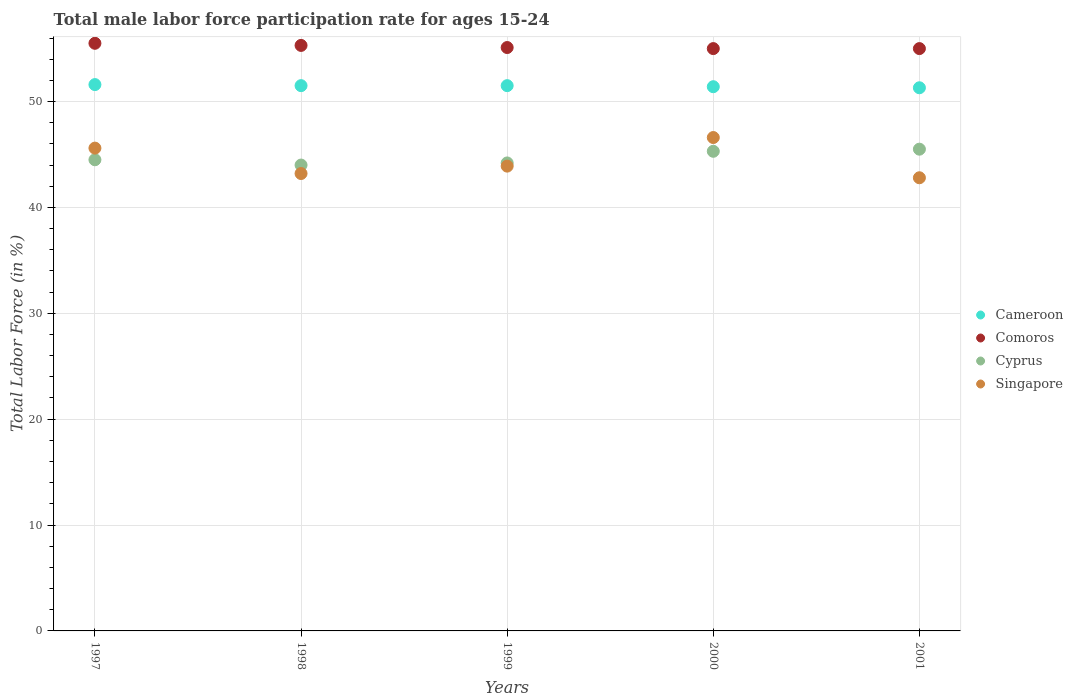How many different coloured dotlines are there?
Keep it short and to the point. 4. Is the number of dotlines equal to the number of legend labels?
Your answer should be very brief. Yes. What is the male labor force participation rate in Cameroon in 2001?
Keep it short and to the point. 51.3. Across all years, what is the maximum male labor force participation rate in Cyprus?
Provide a short and direct response. 45.5. What is the total male labor force participation rate in Cameroon in the graph?
Give a very brief answer. 257.3. What is the difference between the male labor force participation rate in Comoros in 1997 and that in 1999?
Provide a succinct answer. 0.4. What is the difference between the male labor force participation rate in Cameroon in 1997 and the male labor force participation rate in Comoros in 2001?
Your answer should be very brief. -3.4. What is the average male labor force participation rate in Singapore per year?
Your answer should be compact. 44.42. In the year 1997, what is the difference between the male labor force participation rate in Comoros and male labor force participation rate in Cyprus?
Give a very brief answer. 11. In how many years, is the male labor force participation rate in Cameroon greater than 18 %?
Give a very brief answer. 5. What is the ratio of the male labor force participation rate in Singapore in 1998 to that in 2000?
Give a very brief answer. 0.93. What is the difference between the highest and the second highest male labor force participation rate in Comoros?
Ensure brevity in your answer.  0.2. What is the difference between the highest and the lowest male labor force participation rate in Cyprus?
Provide a succinct answer. 1.5. In how many years, is the male labor force participation rate in Singapore greater than the average male labor force participation rate in Singapore taken over all years?
Keep it short and to the point. 2. Is the sum of the male labor force participation rate in Comoros in 1997 and 2000 greater than the maximum male labor force participation rate in Cyprus across all years?
Make the answer very short. Yes. Is it the case that in every year, the sum of the male labor force participation rate in Cameroon and male labor force participation rate in Comoros  is greater than the male labor force participation rate in Cyprus?
Your response must be concise. Yes. Does the male labor force participation rate in Cyprus monotonically increase over the years?
Give a very brief answer. No. Is the male labor force participation rate in Cyprus strictly less than the male labor force participation rate in Singapore over the years?
Ensure brevity in your answer.  No. How many years are there in the graph?
Your response must be concise. 5. Does the graph contain any zero values?
Your answer should be compact. No. Does the graph contain grids?
Your answer should be very brief. Yes. How many legend labels are there?
Your response must be concise. 4. How are the legend labels stacked?
Give a very brief answer. Vertical. What is the title of the graph?
Make the answer very short. Total male labor force participation rate for ages 15-24. Does "Costa Rica" appear as one of the legend labels in the graph?
Ensure brevity in your answer.  No. What is the label or title of the X-axis?
Your answer should be very brief. Years. What is the Total Labor Force (in %) in Cameroon in 1997?
Your answer should be compact. 51.6. What is the Total Labor Force (in %) in Comoros in 1997?
Ensure brevity in your answer.  55.5. What is the Total Labor Force (in %) of Cyprus in 1997?
Your answer should be compact. 44.5. What is the Total Labor Force (in %) in Singapore in 1997?
Make the answer very short. 45.6. What is the Total Labor Force (in %) of Cameroon in 1998?
Offer a terse response. 51.5. What is the Total Labor Force (in %) in Comoros in 1998?
Your answer should be very brief. 55.3. What is the Total Labor Force (in %) in Cyprus in 1998?
Your answer should be compact. 44. What is the Total Labor Force (in %) of Singapore in 1998?
Your answer should be very brief. 43.2. What is the Total Labor Force (in %) in Cameroon in 1999?
Make the answer very short. 51.5. What is the Total Labor Force (in %) of Comoros in 1999?
Provide a short and direct response. 55.1. What is the Total Labor Force (in %) in Cyprus in 1999?
Keep it short and to the point. 44.2. What is the Total Labor Force (in %) in Singapore in 1999?
Offer a terse response. 43.9. What is the Total Labor Force (in %) in Cameroon in 2000?
Make the answer very short. 51.4. What is the Total Labor Force (in %) in Comoros in 2000?
Offer a very short reply. 55. What is the Total Labor Force (in %) in Cyprus in 2000?
Offer a terse response. 45.3. What is the Total Labor Force (in %) of Singapore in 2000?
Provide a short and direct response. 46.6. What is the Total Labor Force (in %) of Cameroon in 2001?
Provide a short and direct response. 51.3. What is the Total Labor Force (in %) of Cyprus in 2001?
Your response must be concise. 45.5. What is the Total Labor Force (in %) in Singapore in 2001?
Offer a terse response. 42.8. Across all years, what is the maximum Total Labor Force (in %) in Cameroon?
Your answer should be very brief. 51.6. Across all years, what is the maximum Total Labor Force (in %) in Comoros?
Make the answer very short. 55.5. Across all years, what is the maximum Total Labor Force (in %) in Cyprus?
Your answer should be very brief. 45.5. Across all years, what is the maximum Total Labor Force (in %) in Singapore?
Your response must be concise. 46.6. Across all years, what is the minimum Total Labor Force (in %) in Cameroon?
Your answer should be very brief. 51.3. Across all years, what is the minimum Total Labor Force (in %) in Comoros?
Your answer should be very brief. 55. Across all years, what is the minimum Total Labor Force (in %) of Singapore?
Your answer should be very brief. 42.8. What is the total Total Labor Force (in %) of Cameroon in the graph?
Make the answer very short. 257.3. What is the total Total Labor Force (in %) of Comoros in the graph?
Your answer should be compact. 275.9. What is the total Total Labor Force (in %) of Cyprus in the graph?
Provide a short and direct response. 223.5. What is the total Total Labor Force (in %) of Singapore in the graph?
Your answer should be very brief. 222.1. What is the difference between the Total Labor Force (in %) of Cameroon in 1997 and that in 1998?
Your response must be concise. 0.1. What is the difference between the Total Labor Force (in %) of Comoros in 1997 and that in 1998?
Ensure brevity in your answer.  0.2. What is the difference between the Total Labor Force (in %) in Cyprus in 1997 and that in 1998?
Offer a very short reply. 0.5. What is the difference between the Total Labor Force (in %) in Singapore in 1997 and that in 1998?
Offer a very short reply. 2.4. What is the difference between the Total Labor Force (in %) in Cameroon in 1997 and that in 1999?
Offer a terse response. 0.1. What is the difference between the Total Labor Force (in %) in Cyprus in 1997 and that in 1999?
Your answer should be compact. 0.3. What is the difference between the Total Labor Force (in %) of Cameroon in 1997 and that in 2000?
Provide a short and direct response. 0.2. What is the difference between the Total Labor Force (in %) of Comoros in 1997 and that in 2000?
Keep it short and to the point. 0.5. What is the difference between the Total Labor Force (in %) of Cyprus in 1997 and that in 2000?
Your answer should be very brief. -0.8. What is the difference between the Total Labor Force (in %) in Singapore in 1997 and that in 2000?
Make the answer very short. -1. What is the difference between the Total Labor Force (in %) in Comoros in 1997 and that in 2001?
Your answer should be compact. 0.5. What is the difference between the Total Labor Force (in %) in Cyprus in 1997 and that in 2001?
Your answer should be compact. -1. What is the difference between the Total Labor Force (in %) in Singapore in 1997 and that in 2001?
Provide a succinct answer. 2.8. What is the difference between the Total Labor Force (in %) of Cameroon in 1998 and that in 1999?
Your answer should be very brief. 0. What is the difference between the Total Labor Force (in %) in Comoros in 1998 and that in 1999?
Offer a terse response. 0.2. What is the difference between the Total Labor Force (in %) of Cyprus in 1998 and that in 1999?
Offer a terse response. -0.2. What is the difference between the Total Labor Force (in %) of Cameroon in 1998 and that in 2000?
Give a very brief answer. 0.1. What is the difference between the Total Labor Force (in %) of Comoros in 1998 and that in 2000?
Make the answer very short. 0.3. What is the difference between the Total Labor Force (in %) of Cyprus in 1998 and that in 2000?
Keep it short and to the point. -1.3. What is the difference between the Total Labor Force (in %) of Singapore in 1998 and that in 2000?
Your answer should be compact. -3.4. What is the difference between the Total Labor Force (in %) in Cameroon in 1998 and that in 2001?
Offer a very short reply. 0.2. What is the difference between the Total Labor Force (in %) in Cyprus in 1998 and that in 2001?
Provide a short and direct response. -1.5. What is the difference between the Total Labor Force (in %) in Singapore in 1999 and that in 2001?
Provide a succinct answer. 1.1. What is the difference between the Total Labor Force (in %) in Comoros in 2000 and that in 2001?
Provide a succinct answer. 0. What is the difference between the Total Labor Force (in %) in Cyprus in 2000 and that in 2001?
Keep it short and to the point. -0.2. What is the difference between the Total Labor Force (in %) of Singapore in 2000 and that in 2001?
Keep it short and to the point. 3.8. What is the difference between the Total Labor Force (in %) of Cameroon in 1997 and the Total Labor Force (in %) of Cyprus in 1999?
Keep it short and to the point. 7.4. What is the difference between the Total Labor Force (in %) of Cameroon in 1997 and the Total Labor Force (in %) of Singapore in 1999?
Ensure brevity in your answer.  7.7. What is the difference between the Total Labor Force (in %) in Cyprus in 1997 and the Total Labor Force (in %) in Singapore in 1999?
Your answer should be very brief. 0.6. What is the difference between the Total Labor Force (in %) in Cameroon in 1997 and the Total Labor Force (in %) in Cyprus in 2000?
Ensure brevity in your answer.  6.3. What is the difference between the Total Labor Force (in %) in Comoros in 1997 and the Total Labor Force (in %) in Cyprus in 2000?
Keep it short and to the point. 10.2. What is the difference between the Total Labor Force (in %) in Comoros in 1997 and the Total Labor Force (in %) in Singapore in 2000?
Ensure brevity in your answer.  8.9. What is the difference between the Total Labor Force (in %) of Cyprus in 1997 and the Total Labor Force (in %) of Singapore in 2000?
Provide a short and direct response. -2.1. What is the difference between the Total Labor Force (in %) in Cameroon in 1997 and the Total Labor Force (in %) in Comoros in 2001?
Your answer should be compact. -3.4. What is the difference between the Total Labor Force (in %) of Cameroon in 1997 and the Total Labor Force (in %) of Cyprus in 2001?
Your answer should be very brief. 6.1. What is the difference between the Total Labor Force (in %) of Cameroon in 1997 and the Total Labor Force (in %) of Singapore in 2001?
Give a very brief answer. 8.8. What is the difference between the Total Labor Force (in %) of Cyprus in 1997 and the Total Labor Force (in %) of Singapore in 2001?
Provide a succinct answer. 1.7. What is the difference between the Total Labor Force (in %) in Cameroon in 1998 and the Total Labor Force (in %) in Cyprus in 1999?
Give a very brief answer. 7.3. What is the difference between the Total Labor Force (in %) of Comoros in 1998 and the Total Labor Force (in %) of Cyprus in 1999?
Your answer should be very brief. 11.1. What is the difference between the Total Labor Force (in %) in Cyprus in 1998 and the Total Labor Force (in %) in Singapore in 1999?
Provide a short and direct response. 0.1. What is the difference between the Total Labor Force (in %) of Cameroon in 1998 and the Total Labor Force (in %) of Cyprus in 2000?
Provide a succinct answer. 6.2. What is the difference between the Total Labor Force (in %) in Cameroon in 1998 and the Total Labor Force (in %) in Singapore in 2000?
Ensure brevity in your answer.  4.9. What is the difference between the Total Labor Force (in %) in Cyprus in 1998 and the Total Labor Force (in %) in Singapore in 2000?
Provide a short and direct response. -2.6. What is the difference between the Total Labor Force (in %) of Cameroon in 1998 and the Total Labor Force (in %) of Comoros in 2001?
Provide a succinct answer. -3.5. What is the difference between the Total Labor Force (in %) in Cameroon in 1998 and the Total Labor Force (in %) in Cyprus in 2001?
Your answer should be compact. 6. What is the difference between the Total Labor Force (in %) in Comoros in 1998 and the Total Labor Force (in %) in Singapore in 2001?
Your response must be concise. 12.5. What is the difference between the Total Labor Force (in %) of Cameroon in 1999 and the Total Labor Force (in %) of Comoros in 2000?
Ensure brevity in your answer.  -3.5. What is the difference between the Total Labor Force (in %) in Cameroon in 1999 and the Total Labor Force (in %) in Cyprus in 2000?
Your response must be concise. 6.2. What is the difference between the Total Labor Force (in %) in Cameroon in 1999 and the Total Labor Force (in %) in Singapore in 2000?
Your answer should be compact. 4.9. What is the difference between the Total Labor Force (in %) in Comoros in 1999 and the Total Labor Force (in %) in Cyprus in 2000?
Offer a terse response. 9.8. What is the difference between the Total Labor Force (in %) of Comoros in 1999 and the Total Labor Force (in %) of Singapore in 2000?
Provide a short and direct response. 8.5. What is the difference between the Total Labor Force (in %) in Cyprus in 1999 and the Total Labor Force (in %) in Singapore in 2000?
Your answer should be very brief. -2.4. What is the difference between the Total Labor Force (in %) in Cameroon in 1999 and the Total Labor Force (in %) in Comoros in 2001?
Make the answer very short. -3.5. What is the difference between the Total Labor Force (in %) in Cameroon in 1999 and the Total Labor Force (in %) in Singapore in 2001?
Your response must be concise. 8.7. What is the difference between the Total Labor Force (in %) of Comoros in 1999 and the Total Labor Force (in %) of Cyprus in 2001?
Your response must be concise. 9.6. What is the difference between the Total Labor Force (in %) of Comoros in 1999 and the Total Labor Force (in %) of Singapore in 2001?
Keep it short and to the point. 12.3. What is the difference between the Total Labor Force (in %) in Cyprus in 1999 and the Total Labor Force (in %) in Singapore in 2001?
Provide a short and direct response. 1.4. What is the difference between the Total Labor Force (in %) of Comoros in 2000 and the Total Labor Force (in %) of Singapore in 2001?
Your response must be concise. 12.2. What is the difference between the Total Labor Force (in %) in Cyprus in 2000 and the Total Labor Force (in %) in Singapore in 2001?
Your answer should be very brief. 2.5. What is the average Total Labor Force (in %) in Cameroon per year?
Make the answer very short. 51.46. What is the average Total Labor Force (in %) in Comoros per year?
Keep it short and to the point. 55.18. What is the average Total Labor Force (in %) in Cyprus per year?
Provide a succinct answer. 44.7. What is the average Total Labor Force (in %) of Singapore per year?
Ensure brevity in your answer.  44.42. In the year 1997, what is the difference between the Total Labor Force (in %) in Cameroon and Total Labor Force (in %) in Cyprus?
Your response must be concise. 7.1. In the year 1997, what is the difference between the Total Labor Force (in %) of Comoros and Total Labor Force (in %) of Cyprus?
Your answer should be compact. 11. In the year 1997, what is the difference between the Total Labor Force (in %) of Comoros and Total Labor Force (in %) of Singapore?
Provide a short and direct response. 9.9. In the year 1998, what is the difference between the Total Labor Force (in %) of Cameroon and Total Labor Force (in %) of Comoros?
Provide a succinct answer. -3.8. In the year 1998, what is the difference between the Total Labor Force (in %) of Comoros and Total Labor Force (in %) of Cyprus?
Make the answer very short. 11.3. In the year 1999, what is the difference between the Total Labor Force (in %) in Cameroon and Total Labor Force (in %) in Comoros?
Provide a succinct answer. -3.6. In the year 1999, what is the difference between the Total Labor Force (in %) in Comoros and Total Labor Force (in %) in Cyprus?
Provide a short and direct response. 10.9. In the year 1999, what is the difference between the Total Labor Force (in %) in Comoros and Total Labor Force (in %) in Singapore?
Give a very brief answer. 11.2. In the year 1999, what is the difference between the Total Labor Force (in %) in Cyprus and Total Labor Force (in %) in Singapore?
Provide a succinct answer. 0.3. In the year 2000, what is the difference between the Total Labor Force (in %) in Cameroon and Total Labor Force (in %) in Cyprus?
Your answer should be compact. 6.1. In the year 2000, what is the difference between the Total Labor Force (in %) of Cyprus and Total Labor Force (in %) of Singapore?
Your answer should be compact. -1.3. In the year 2001, what is the difference between the Total Labor Force (in %) in Cameroon and Total Labor Force (in %) in Comoros?
Provide a succinct answer. -3.7. In the year 2001, what is the difference between the Total Labor Force (in %) in Cameroon and Total Labor Force (in %) in Cyprus?
Provide a short and direct response. 5.8. In the year 2001, what is the difference between the Total Labor Force (in %) of Cameroon and Total Labor Force (in %) of Singapore?
Keep it short and to the point. 8.5. In the year 2001, what is the difference between the Total Labor Force (in %) of Comoros and Total Labor Force (in %) of Cyprus?
Provide a short and direct response. 9.5. In the year 2001, what is the difference between the Total Labor Force (in %) in Cyprus and Total Labor Force (in %) in Singapore?
Ensure brevity in your answer.  2.7. What is the ratio of the Total Labor Force (in %) of Comoros in 1997 to that in 1998?
Provide a short and direct response. 1. What is the ratio of the Total Labor Force (in %) in Cyprus in 1997 to that in 1998?
Your answer should be very brief. 1.01. What is the ratio of the Total Labor Force (in %) in Singapore in 1997 to that in 1998?
Offer a very short reply. 1.06. What is the ratio of the Total Labor Force (in %) of Cameroon in 1997 to that in 1999?
Give a very brief answer. 1. What is the ratio of the Total Labor Force (in %) in Comoros in 1997 to that in 1999?
Your answer should be compact. 1.01. What is the ratio of the Total Labor Force (in %) of Cyprus in 1997 to that in 1999?
Provide a short and direct response. 1.01. What is the ratio of the Total Labor Force (in %) of Singapore in 1997 to that in 1999?
Your answer should be compact. 1.04. What is the ratio of the Total Labor Force (in %) of Comoros in 1997 to that in 2000?
Your response must be concise. 1.01. What is the ratio of the Total Labor Force (in %) in Cyprus in 1997 to that in 2000?
Give a very brief answer. 0.98. What is the ratio of the Total Labor Force (in %) in Singapore in 1997 to that in 2000?
Your answer should be compact. 0.98. What is the ratio of the Total Labor Force (in %) of Comoros in 1997 to that in 2001?
Offer a terse response. 1.01. What is the ratio of the Total Labor Force (in %) in Singapore in 1997 to that in 2001?
Keep it short and to the point. 1.07. What is the ratio of the Total Labor Force (in %) of Comoros in 1998 to that in 1999?
Make the answer very short. 1. What is the ratio of the Total Labor Force (in %) in Singapore in 1998 to that in 1999?
Your answer should be compact. 0.98. What is the ratio of the Total Labor Force (in %) in Cyprus in 1998 to that in 2000?
Give a very brief answer. 0.97. What is the ratio of the Total Labor Force (in %) of Singapore in 1998 to that in 2000?
Provide a succinct answer. 0.93. What is the ratio of the Total Labor Force (in %) in Cameroon in 1998 to that in 2001?
Ensure brevity in your answer.  1. What is the ratio of the Total Labor Force (in %) of Singapore in 1998 to that in 2001?
Offer a very short reply. 1.01. What is the ratio of the Total Labor Force (in %) in Cameroon in 1999 to that in 2000?
Offer a very short reply. 1. What is the ratio of the Total Labor Force (in %) of Cyprus in 1999 to that in 2000?
Your answer should be compact. 0.98. What is the ratio of the Total Labor Force (in %) in Singapore in 1999 to that in 2000?
Ensure brevity in your answer.  0.94. What is the ratio of the Total Labor Force (in %) of Comoros in 1999 to that in 2001?
Offer a terse response. 1. What is the ratio of the Total Labor Force (in %) in Cyprus in 1999 to that in 2001?
Give a very brief answer. 0.97. What is the ratio of the Total Labor Force (in %) of Singapore in 1999 to that in 2001?
Your answer should be compact. 1.03. What is the ratio of the Total Labor Force (in %) in Cameroon in 2000 to that in 2001?
Make the answer very short. 1. What is the ratio of the Total Labor Force (in %) of Cyprus in 2000 to that in 2001?
Your answer should be compact. 1. What is the ratio of the Total Labor Force (in %) of Singapore in 2000 to that in 2001?
Provide a short and direct response. 1.09. What is the difference between the highest and the second highest Total Labor Force (in %) of Cameroon?
Make the answer very short. 0.1. What is the difference between the highest and the second highest Total Labor Force (in %) of Comoros?
Your answer should be compact. 0.2. What is the difference between the highest and the second highest Total Labor Force (in %) of Singapore?
Your response must be concise. 1. What is the difference between the highest and the lowest Total Labor Force (in %) of Cameroon?
Provide a succinct answer. 0.3. 